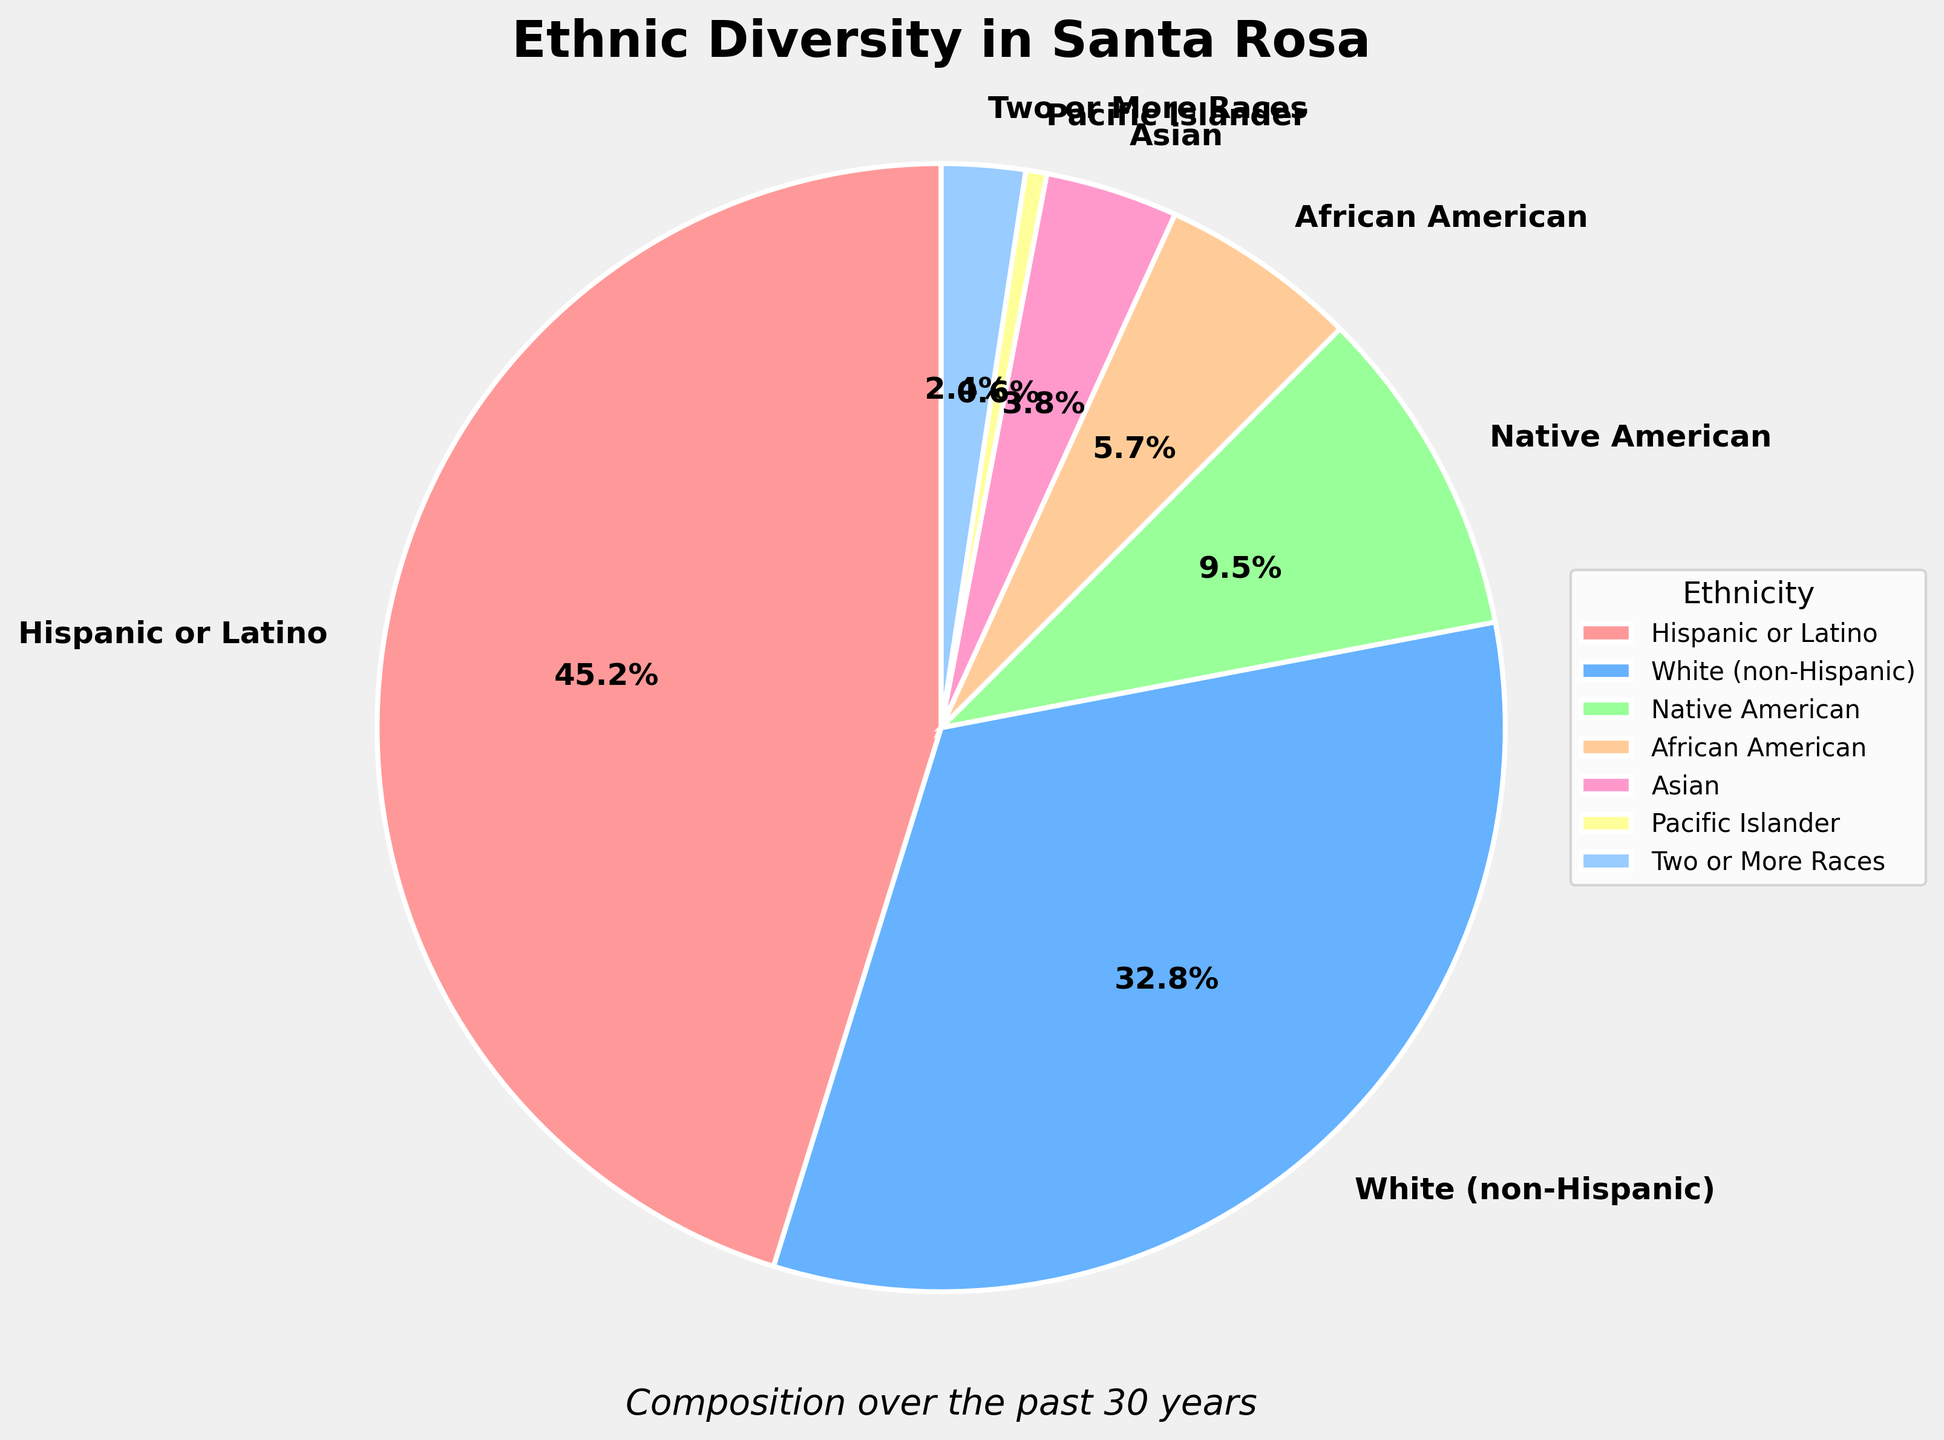What is the largest ethnic group in Santa Rosa based on the pie chart? The largest ethnic group can be identified by looking at the segment of the pie chart that represents the highest percentage. Here, the "Hispanic or Latino" group has the largest section at 45.2%.
Answer: Hispanic or Latino Which two ethnic groups together make up more than half of the population in Santa Rosa? To find two groups that together make up more than 50% of the population, look for the two largest segments and add their percentages. The "Hispanic or Latino" group (45.2%) and the "White (non-Hispanic)" group (32.8%) together make up 45.2% + 32.8% = 78.0%, which is more than half.
Answer: Hispanic or Latino and White (non-Hispanic) Which ethnic group has the smallest representation in the composition of Santa Rosa's ethnic diversity? The smallest ethnic group can be identified by locating the smallest segment of the pie chart. Here, the "Pacific Islander" group is the smallest at 0.6%.
Answer: Pacific Islander By how much is the Hispanic or Latino population percentage greater than the African American population percentage? Subtract the percentage of the African American group (5.7%) from the percentage of the Hispanic or Latino group (45.2%). The difference is 45.2% - 5.7% = 39.5%.
Answer: 39.5% What is the combined percentage of Native American and Asian populations in Santa Rosa? Add the percentage for the Native American group (9.5%) to the percentage for the Asian group (3.8%). Therefore, 9.5% + 3.8% = 13.3%.
Answer: 13.3% Which three ethnic groups contribute the least to the total composition in Santa Rosa? Identify the three smallest segments of the pie chart. The smallest three groups are "Pacific Islander" (0.6%), "Two or More Races" (2.4%), and "Asian" (3.8%).
Answer: Pacific Islander, Two or More Races, and Asian Is the representation of the White (non-Hispanic) group less than half that of the Hispanic or Latino group? Compare the percentage of the White (non-Hispanic) group (32.8%) to half of the percentage of the Hispanic or Latino group (45.2% / 2 = 22.6%). Since 32.8% is greater than 22.6%, the representation of the White group is not less than half of the Hispanic or Latino group.
Answer: No What percentage of the population is made up by groups other than the Hispanic or Latino and White (non-Hispanic) groups? Subtract the combined percentage of the Hispanic or Latino group (45.2%) and the White (non-Hispanic) group (32.8%) from the total population (100%). So, 100% - (45.2% + 32.8%) = 100% - 78.0% = 22.0%.
Answer: 22.0% How does the visual representation of the Two or More Races group compare to the Native American group? Visually, compare the segments representing the Two or More Races group and the Native American group. Notice that the segment for "Two or More Races" (2.4%) is significantly smaller than the segment for "Native American" (9.5%).
Answer: The Two or More Races segment is smaller What are the second and third most represented ethnic groups in Santa Rosa? Identify the second and third largest segments of the pie chart after the largest one. The second largest is "White (non-Hispanic)" at 32.8% and the third largest is "Native American" at 9.5%.
Answer: White (non-Hispanic) and Native American 